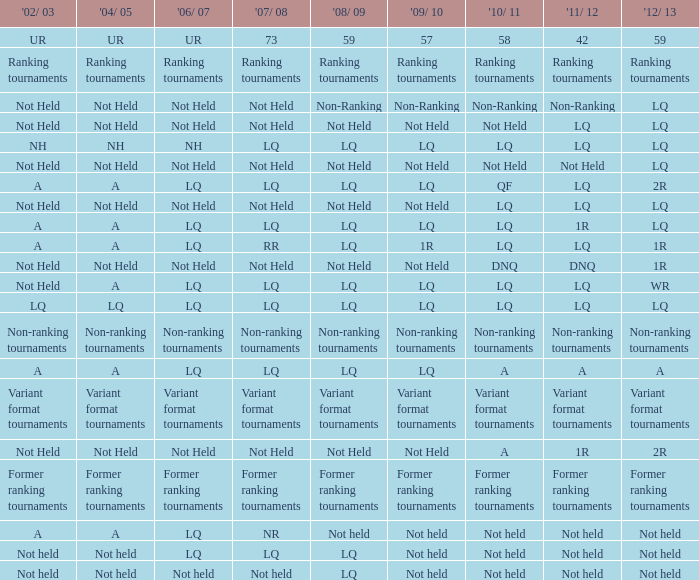Name the 2010/11 with 2004/05 of not held and 2011/12 of non-ranking Non-Ranking. 